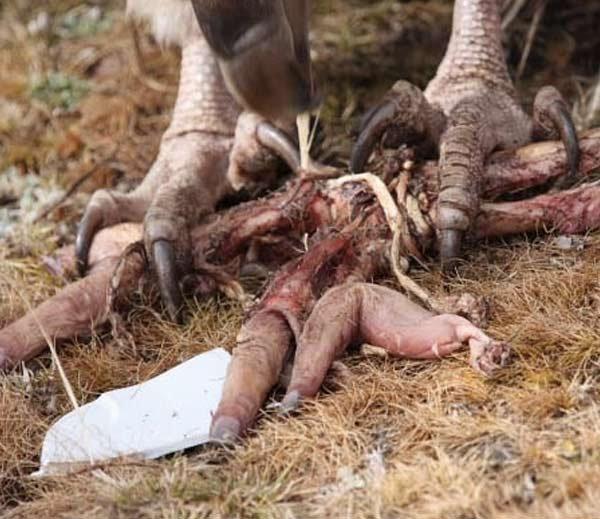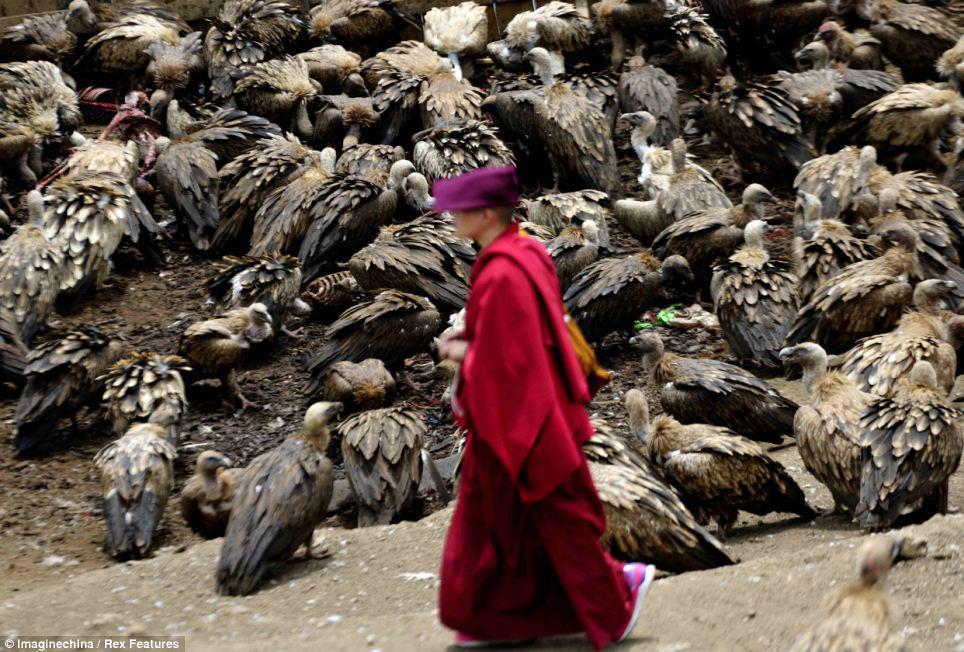The first image is the image on the left, the second image is the image on the right. Considering the images on both sides, is "An image contains a mass of vultures and a living creature that is not a bird." valid? Answer yes or no. Yes. The first image is the image on the left, the second image is the image on the right. Analyze the images presented: Is the assertion "One of the meals is an antelope like creature, such as a deer." valid? Answer yes or no. No. 